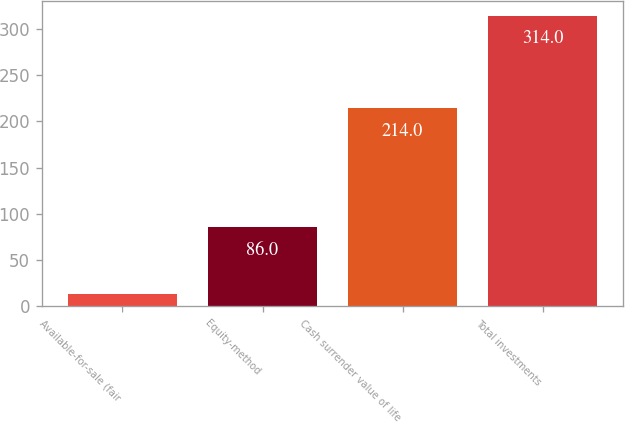<chart> <loc_0><loc_0><loc_500><loc_500><bar_chart><fcel>Available-for-sale (fair<fcel>Equity-method<fcel>Cash surrender value of life<fcel>Total investments<nl><fcel>14<fcel>86<fcel>214<fcel>314<nl></chart> 